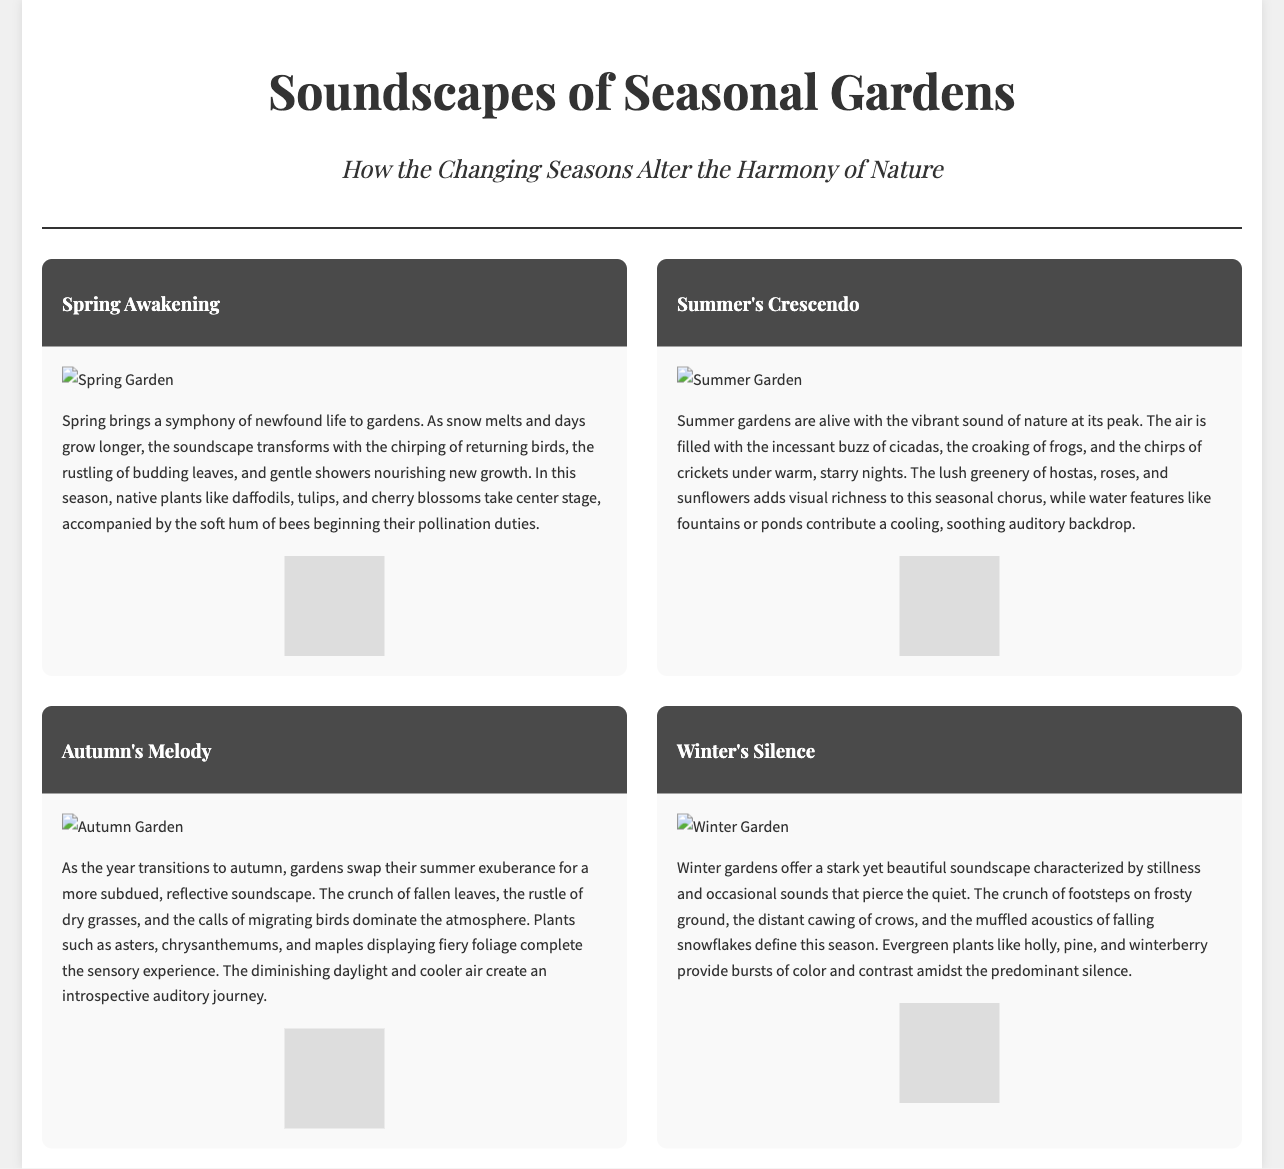What season is described as "Spring Awakening"? The document specifically states that "Spring Awakening" is a section title describing the atmosphere of spring in gardens.
Answer: Spring Awakening What type of plants are highlighted in summer gardens? The document mentions hostas, roses, and sunflowers as the lush greenery found in summer gardens.
Answer: Hostas, roses, and sunflowers What auditory background is associated with autumn gardens? The soundscape of autumn is characterized by the crunch of fallen leaves, rustle of dry grasses, and calls of migrating birds according to the article.
Answer: Crunch of fallen leaves, rustle of dry grasses, and calls of migrating birds What item linked to soundtracks is included in each seasonal section? Each section of the document features a QR code that links to curated ambient soundtracks for the respective season.
Answer: QR code Which season is described with a soundscape characterized by "stillness"? The document refers to winter gardens as having a soundscape defined by stillness and occasional sounds.
Answer: Winter How many sections are there in the document? The document contains four distinct sections dedicated to each of the seasons: spring, summer, autumn, and winter.
Answer: Four What feature enhances the visual appeal of each season's section? The sections each include detailed photos that visually represent the seasonal gardens described in the document, enhancing overall engagement.
Answer: Detailed photos What is the main topic of the header in the document? The header's main topic focuses on how soundscapes in gardens change with each season, as indicated in the title and subtitle.
Answer: Soundscapes of Seasonal Gardens 